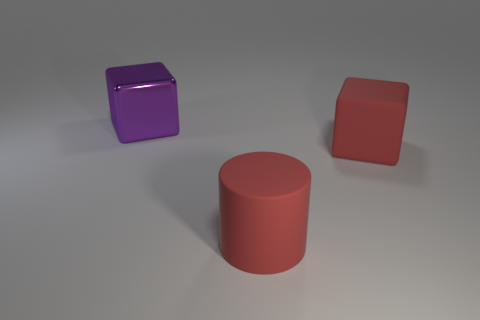Add 1 big yellow shiny balls. How many objects exist? 4 Subtract all cylinders. How many objects are left? 2 Subtract 0 green balls. How many objects are left? 3 Subtract all large red rubber objects. Subtract all big brown shiny balls. How many objects are left? 1 Add 1 red things. How many red things are left? 3 Add 2 yellow shiny things. How many yellow shiny things exist? 2 